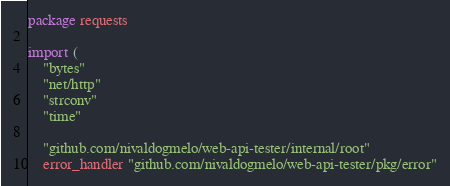Convert code to text. <code><loc_0><loc_0><loc_500><loc_500><_Go_>package requests

import (
	"bytes"
	"net/http"
	"strconv"
	"time"

	"github.com/nivaldogmelo/web-api-tester/internal/root"
	error_handler "github.com/nivaldogmelo/web-api-tester/pkg/error"</code> 